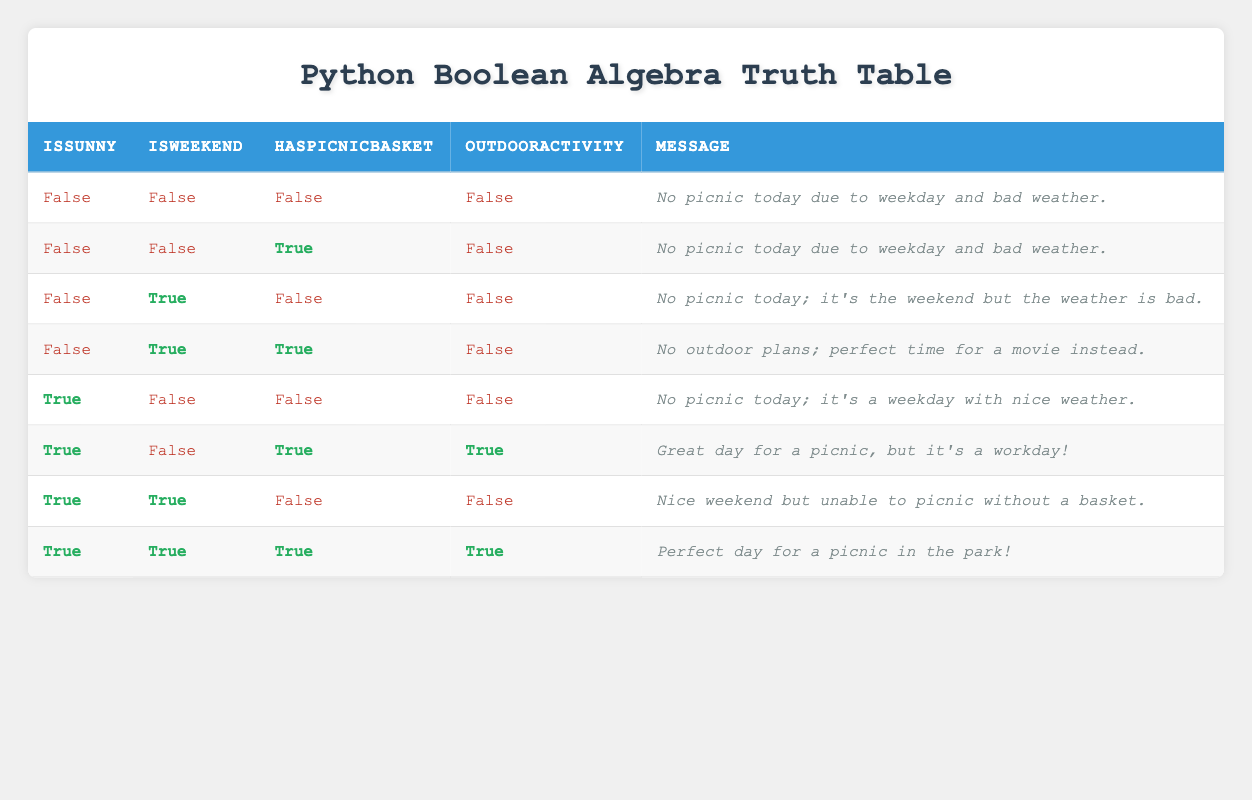What is the message when it is sunny and a picnic basket is available on a weekend? In the truth table, when "IsSunny" is true, "IsWeekend" is true, and "HasPicnicBasket" is true, the message indicates "Perfect day for a picnic in the park!"
Answer: Perfect day for a picnic in the park! How many scenarios have an outdoor activity planned? By looking through the table, there are only two rows where "OutdoorActivity" is true (rows where both weather is sunny and there’s a picnic basket). Counting those gives a total of 2 scenarios.
Answer: 2 Is there any scenario where it is sunny, the weekend, but without a picnic basket? Yes, in the fourth row of the table, it lists "IsSunny" as true, "IsWeekend" as true, and "HasPicnicBasket" as false; thus confirming the condition shows up in the table.
Answer: Yes In how many scenarios is there no picnic, regardless of the weather? Reviewing the table shows four rows where "OutdoorActivity" is false (first, second, third, and fourth rows). Thus, the number of scenarios where there’s no picnic is 4.
Answer: 4 If it is sunny, how many scenarios involve a picnic basket? The truth table reveals three scenarios where "IsSunny" is true and "HasPicnicBasket" is true (the sixth and eighth rows). Therefore, the total of such scenarios is 2.
Answer: 2 What is the overall condition for having an outdoor activity? An outdoor activity is possible when both "IsSunny" and "HasPicnicBasket" are true, irrespective of the weekend status, which happens in two specific cases shown in the table (the sixth and eighth rows).
Answer: Both sunny and picnic basket required Is there any weekend scenario without an outdoor activity where it is sunny? Yes, according to the table, when "IsSunny" is true, "IsWeekend" is true, and "HasPicnicBasket" is false (seventh row), the response states that there are no picnic plans.
Answer: Yes Under what conditions can we say it's not a picnic day due to bad weather? The table lists multiple rows where bad weather is indicated by "IsSunny" being false; particularly, this shows up in the first two rows and the third row as well. Hence, there are three conditions confirming no picnic due to bad weather.
Answer: 3 What conclusion can be drawn about having a picnic on a sunny weekend? Analyzing the table, we find on sunny weekends, there are two possible outcomes: having a picnic with a basket or not, concluding that having the basket is essential for a picnic.
Answer: Having a basket is essential for a picnic 